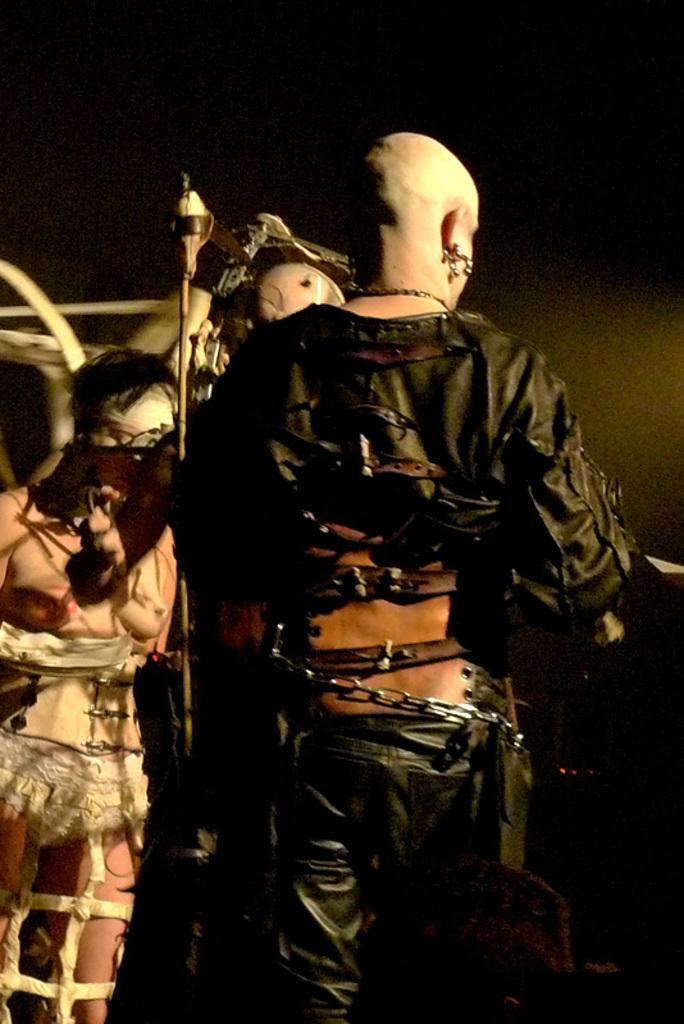Describe this image in one or two sentences. In this picture we can see some people standing here, they wore costumes, we can see a chain here, in the background there is a wall. 